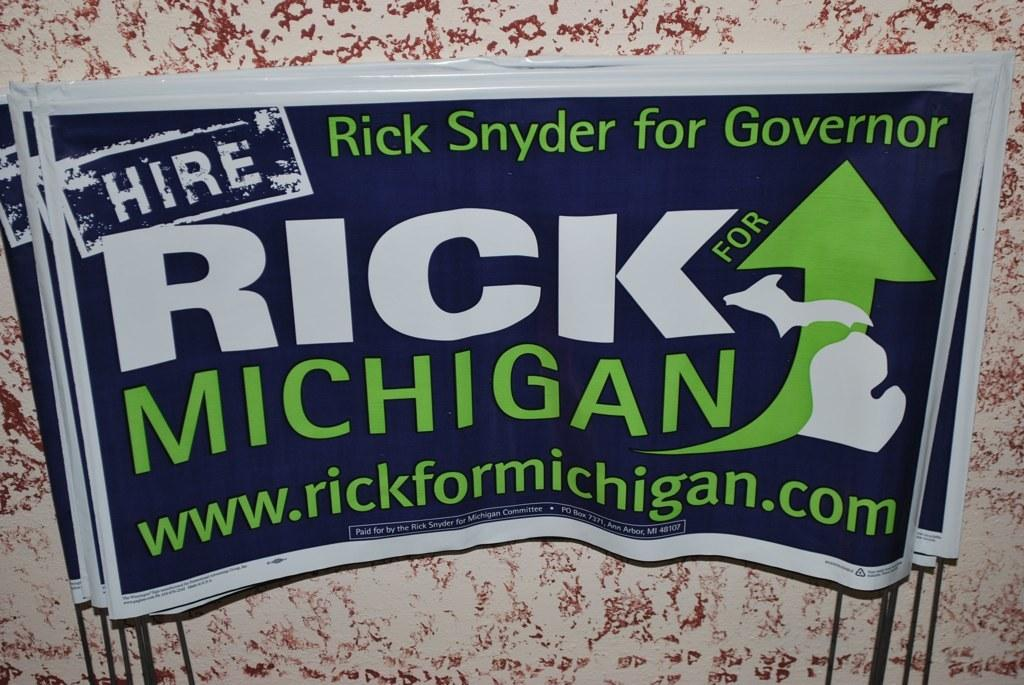<image>
Give a short and clear explanation of the subsequent image. Rick Snyder ran for Governor of Michigan at least one time. 